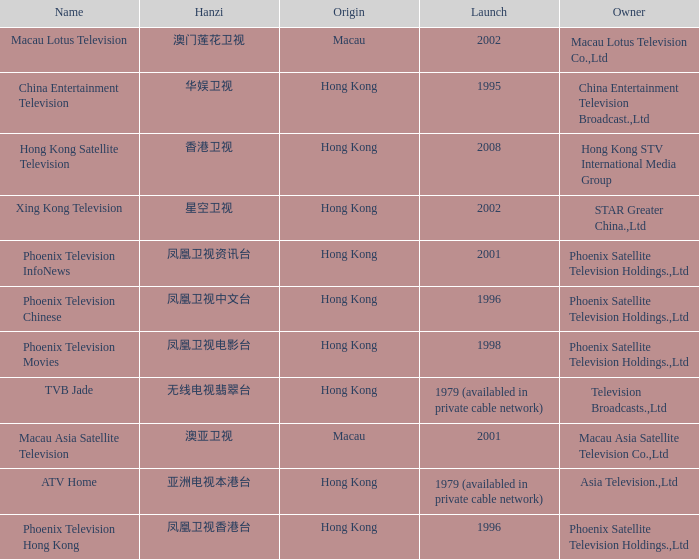What is the Hanzi of Phoenix Television Chinese that launched in 1996? 凤凰卫视中文台. 